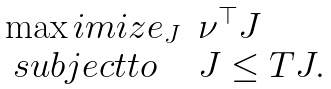Convert formula to latex. <formula><loc_0><loc_0><loc_500><loc_500>\begin{array} { l l l } \max i m i z e _ { J } & \nu ^ { \top } J \\ \ s u b j e c t t o & J \leq T J . \end{array}</formula> 